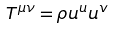Convert formula to latex. <formula><loc_0><loc_0><loc_500><loc_500>T ^ { \mu \nu } = \rho u ^ { u } u ^ { v }</formula> 